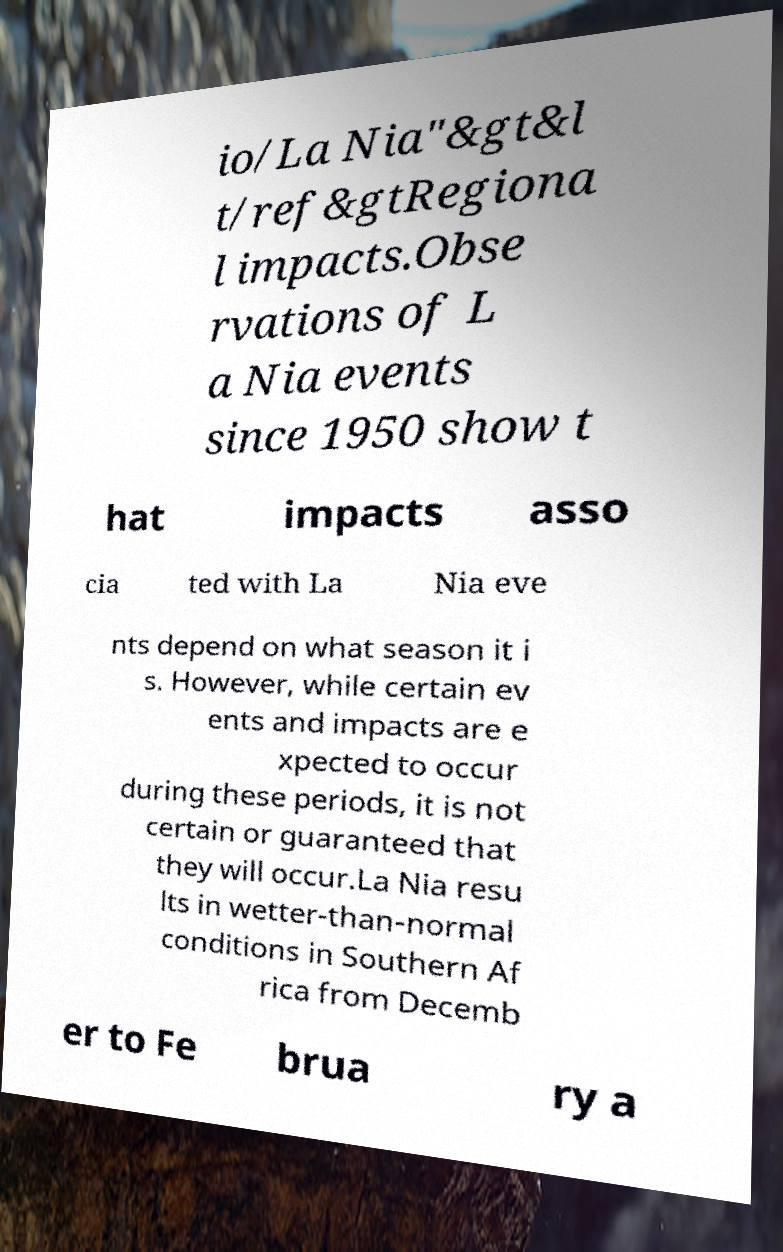I need the written content from this picture converted into text. Can you do that? io/La Nia"&gt&l t/ref&gtRegiona l impacts.Obse rvations of L a Nia events since 1950 show t hat impacts asso cia ted with La Nia eve nts depend on what season it i s. However, while certain ev ents and impacts are e xpected to occur during these periods, it is not certain or guaranteed that they will occur.La Nia resu lts in wetter-than-normal conditions in Southern Af rica from Decemb er to Fe brua ry a 